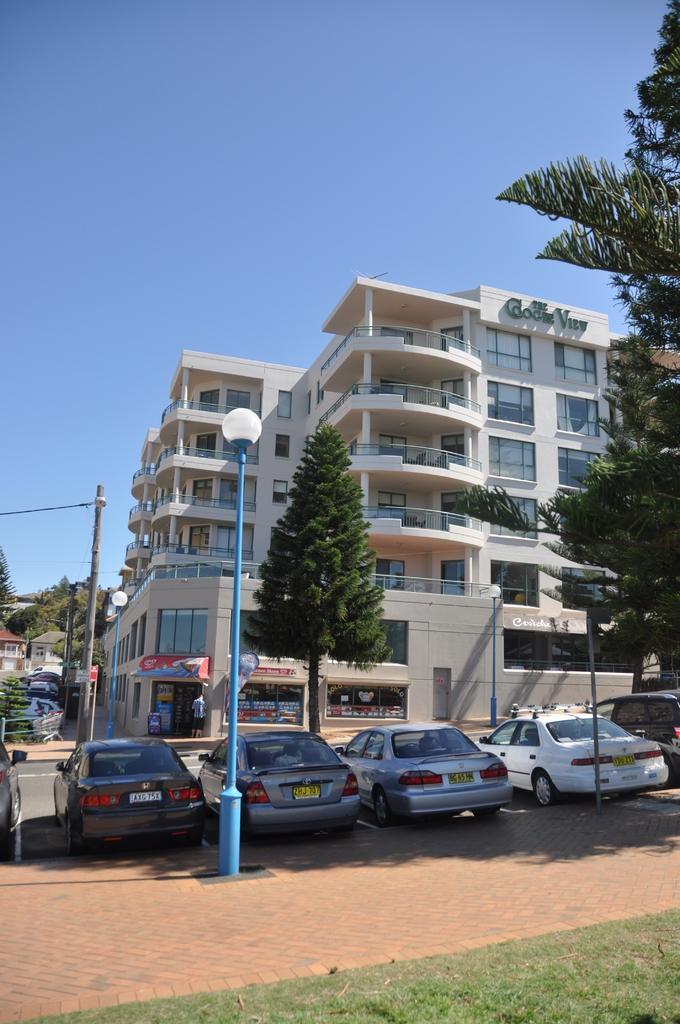Describe this image in one or two sentences. In this image I can see the grass. I can see the vehicles. In the background, I can see the trees, buildings and the sky. 